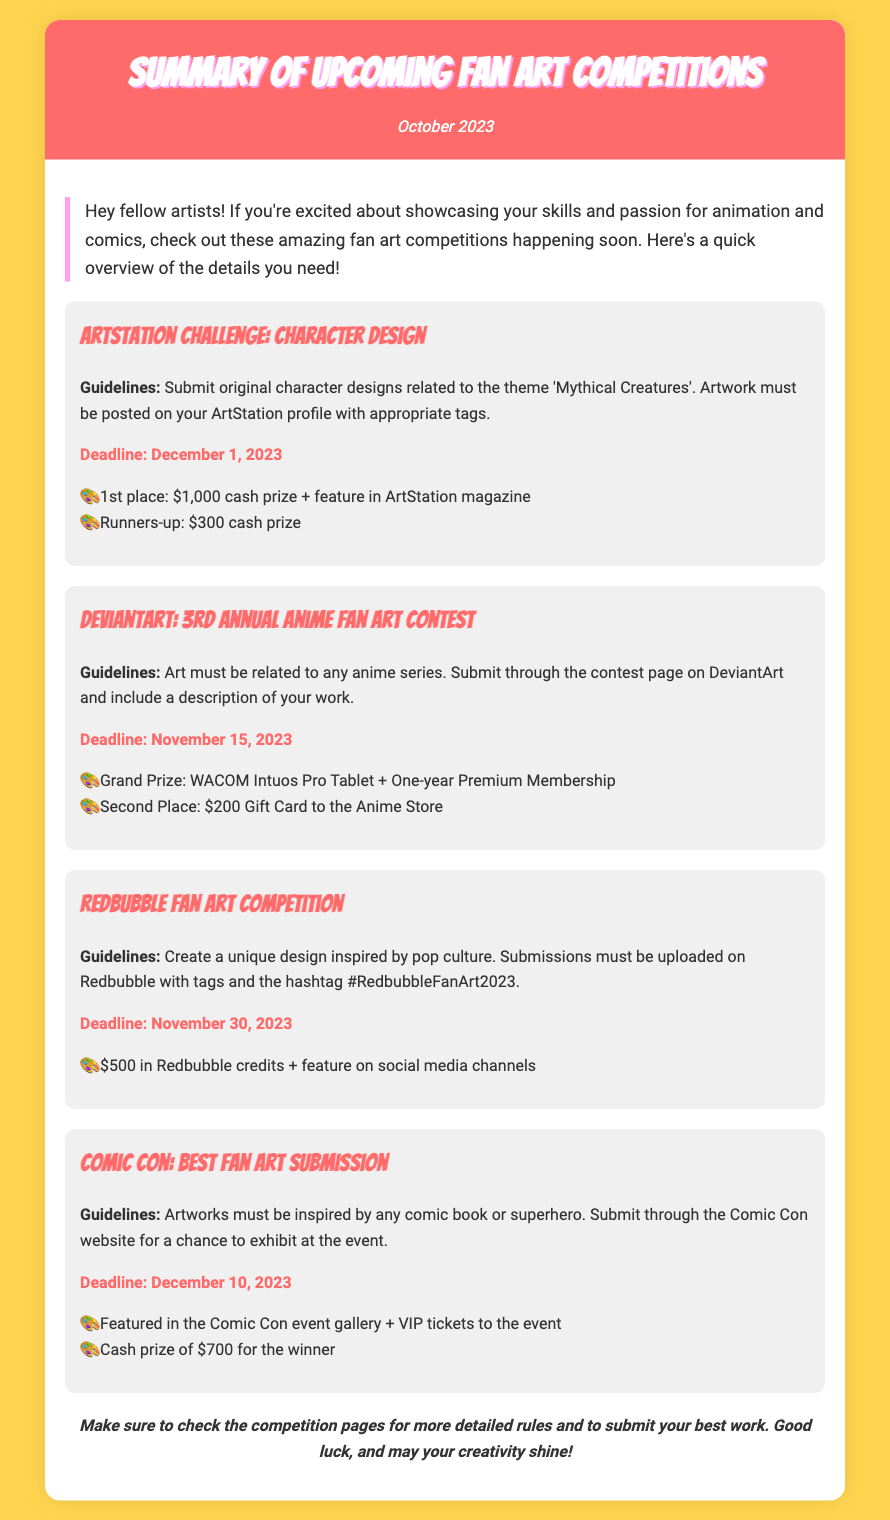What is the theme for the ArtStation Challenge? The theme for the ArtStation Challenge is 'Mythical Creatures'.
Answer: Mythical Creatures What is the cash prize for the 1st place in the ArtStation Challenge? The 1st place prize in the ArtStation Challenge is $1,000 cash prize.
Answer: $1,000 When is the deadline for the DeviantArt contest? The deadline for the DeviantArt contest is November 15, 2023.
Answer: November 15, 2023 What must the submissions for the Redbubble competition include? Submissions for the Redbubble competition must be uploaded on Redbubble with tags and the hashtag #RedbubbleFanArt2023.
Answer: Tags and the hashtag #RedbubbleFanArt2023 What is the grand prize for the DeviantArt contest? The grand prize for the DeviantArt contest is a WACOM Intuos Pro Tablet and one-year Premium Membership.
Answer: WACOM Intuos Pro Tablet + One-year Premium Membership How much is the cash prize for the Comic Con competition winner? The cash prize for the Comic Con competition winner is $700.
Answer: $700 For which type of art must submissions be inspired in the Comic Con competition? Submissions for the Comic Con competition must be inspired by any comic book or superhero.
Answer: Comic book or superhero What is the prize for the winner of the Redbubble Fan Art Competition? The prize for the winner of the Redbubble Fan Art Competition is $500 in Redbubble credits.
Answer: $500 in Redbubble credits 